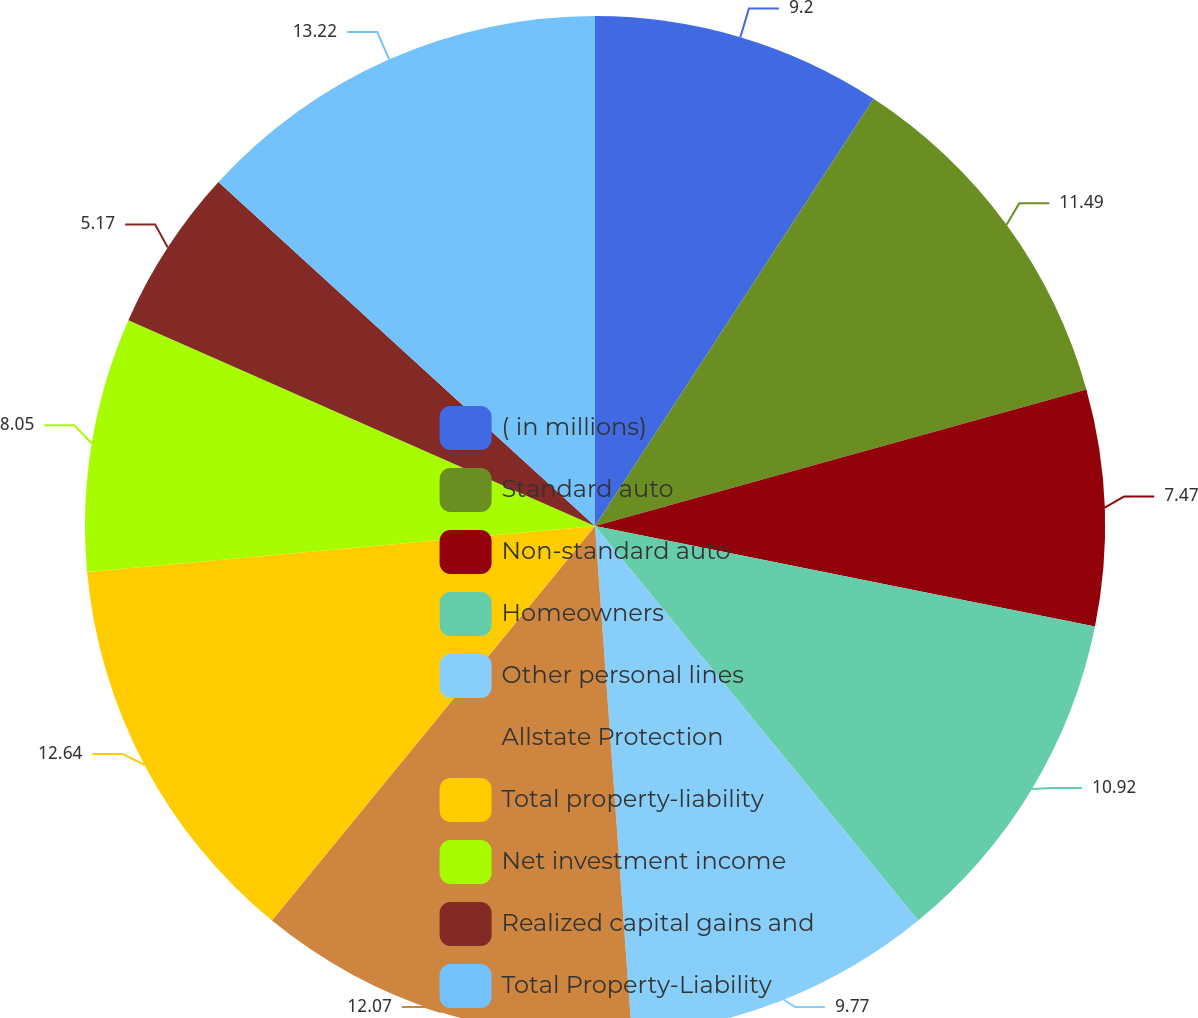Convert chart to OTSL. <chart><loc_0><loc_0><loc_500><loc_500><pie_chart><fcel>( in millions)<fcel>Standard auto<fcel>Non-standard auto<fcel>Homeowners<fcel>Other personal lines<fcel>Allstate Protection<fcel>Total property-liability<fcel>Net investment income<fcel>Realized capital gains and<fcel>Total Property-Liability<nl><fcel>9.2%<fcel>11.49%<fcel>7.47%<fcel>10.92%<fcel>9.77%<fcel>12.07%<fcel>12.64%<fcel>8.05%<fcel>5.17%<fcel>13.22%<nl></chart> 